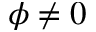Convert formula to latex. <formula><loc_0><loc_0><loc_500><loc_500>\phi \neq 0</formula> 